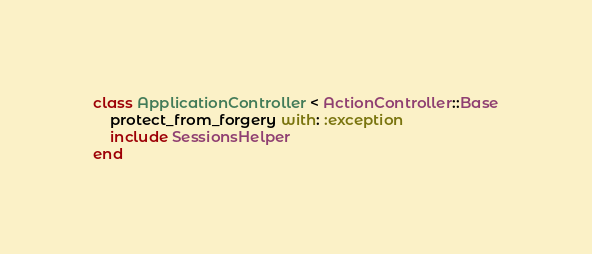Convert code to text. <code><loc_0><loc_0><loc_500><loc_500><_Ruby_>class ApplicationController < ActionController::Base
    protect_from_forgery with: :exception
    include SessionsHelper
end 

</code> 